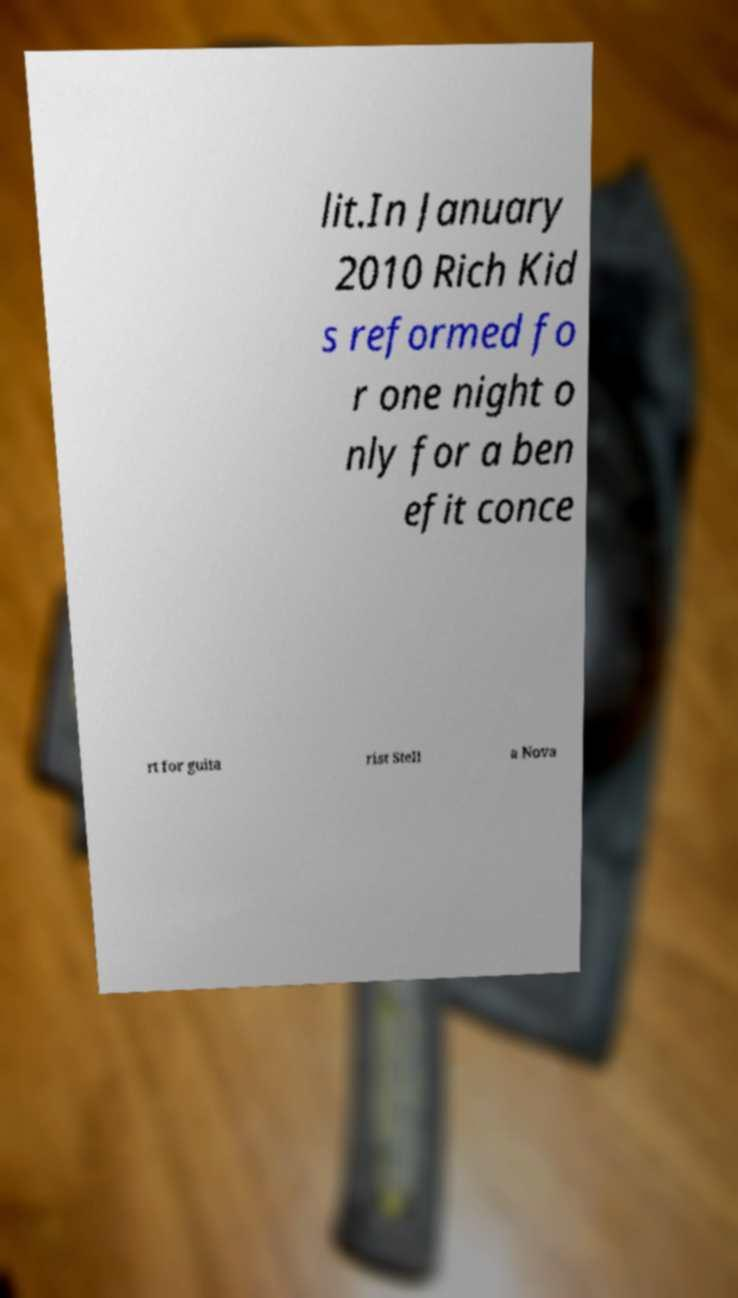There's text embedded in this image that I need extracted. Can you transcribe it verbatim? lit.In January 2010 Rich Kid s reformed fo r one night o nly for a ben efit conce rt for guita rist Stell a Nova 